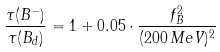<formula> <loc_0><loc_0><loc_500><loc_500>\frac { \tau ( B ^ { - } ) } { \tau ( B _ { d } ) } = 1 + 0 . 0 5 \cdot \frac { f _ { B } ^ { 2 } } { ( 2 0 0 \, M e V ) ^ { 2 } }</formula> 